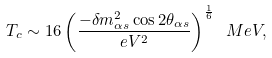<formula> <loc_0><loc_0><loc_500><loc_500>T _ { c } \sim 1 6 \left ( { \frac { - \delta m _ { \alpha s } ^ { 2 } \cos 2 \theta _ { \alpha s } } { e V ^ { 2 } } } \right ) ^ { \frac { 1 } { 6 } } \ M e V ,</formula> 